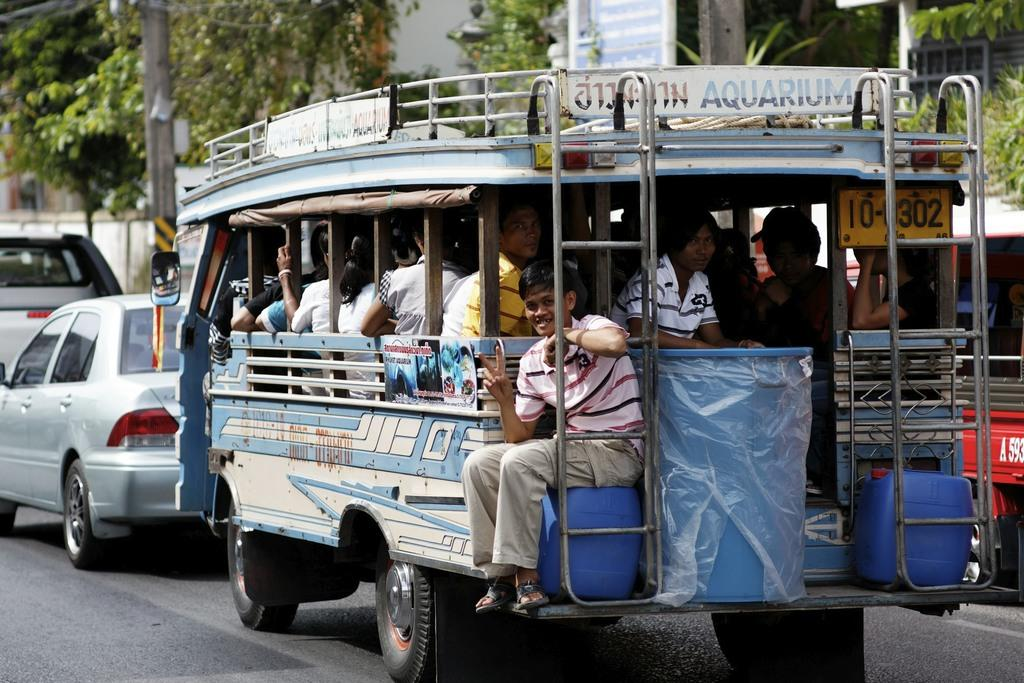What can be seen in the image that has wheels and is used for transportation? There are vehicles in the image that have wheels and are used for transportation. Who is inside the vehicles in the image? There are people sitting in the vehicles in the image. What is located on the left side of the image? There is a pole on the left side of the image. What can be seen in the background of the image? There are trees and a board visible in the background of the image. What type of metal is used to make the place in the image? There is no place mentioned in the image, and therefore no metal can be associated with it. 